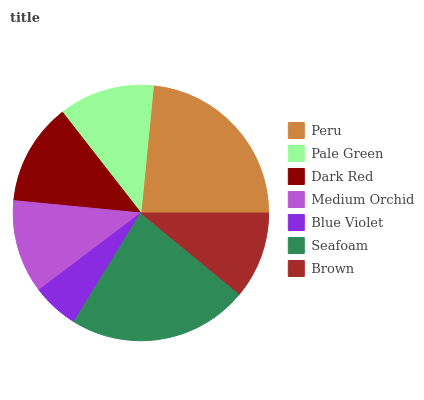Is Blue Violet the minimum?
Answer yes or no. Yes. Is Peru the maximum?
Answer yes or no. Yes. Is Pale Green the minimum?
Answer yes or no. No. Is Pale Green the maximum?
Answer yes or no. No. Is Peru greater than Pale Green?
Answer yes or no. Yes. Is Pale Green less than Peru?
Answer yes or no. Yes. Is Pale Green greater than Peru?
Answer yes or no. No. Is Peru less than Pale Green?
Answer yes or no. No. Is Pale Green the high median?
Answer yes or no. Yes. Is Pale Green the low median?
Answer yes or no. Yes. Is Seafoam the high median?
Answer yes or no. No. Is Peru the low median?
Answer yes or no. No. 